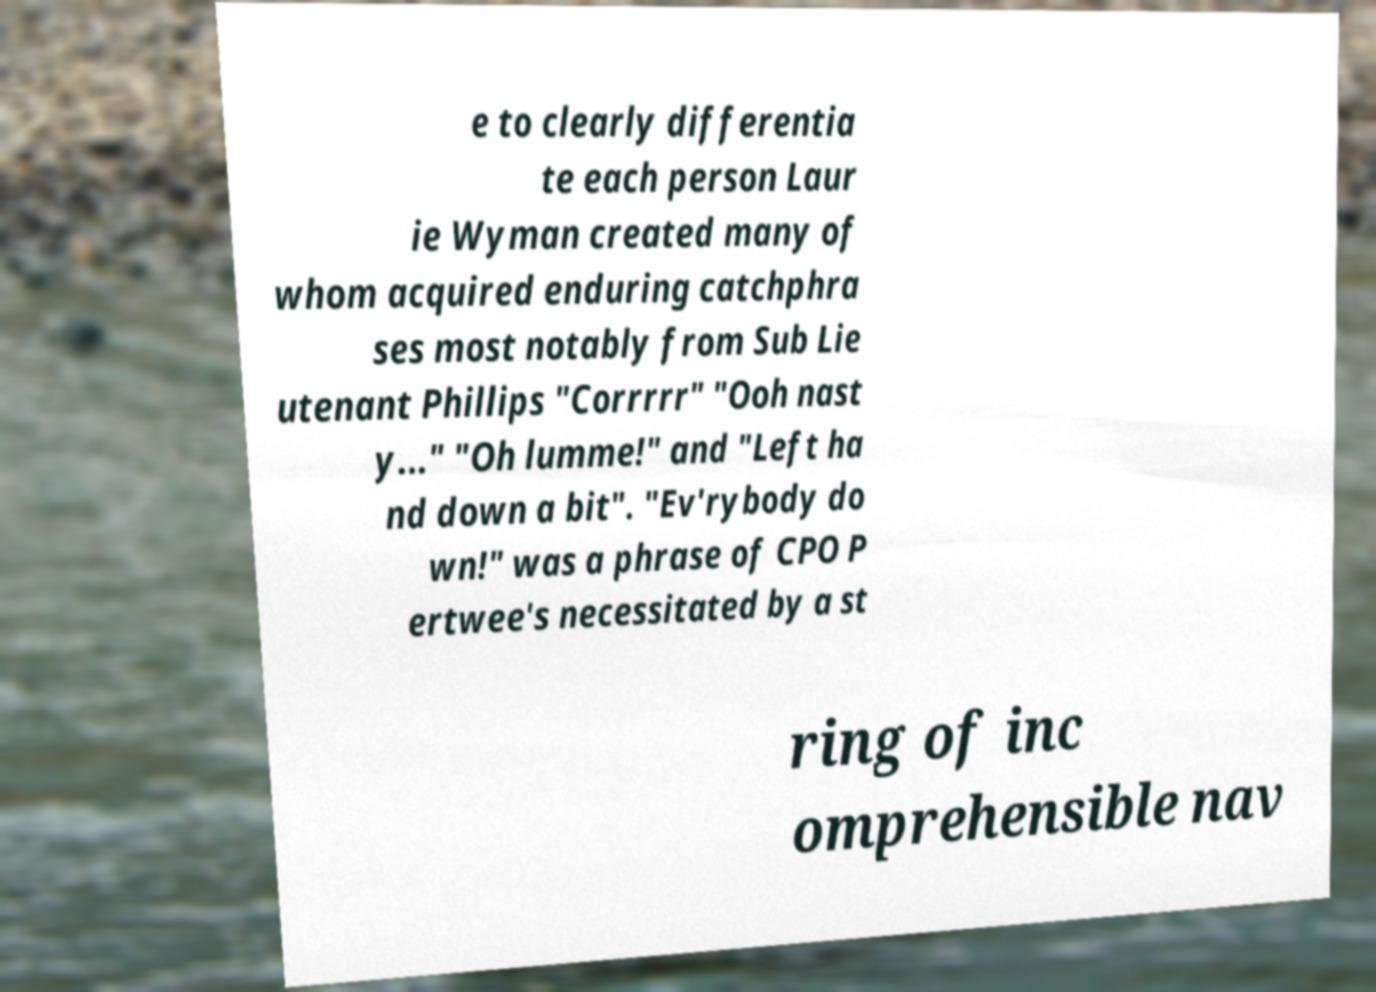Could you assist in decoding the text presented in this image and type it out clearly? e to clearly differentia te each person Laur ie Wyman created many of whom acquired enduring catchphra ses most notably from Sub Lie utenant Phillips "Corrrrr" "Ooh nast y..." "Oh lumme!" and "Left ha nd down a bit". "Ev'rybody do wn!" was a phrase of CPO P ertwee's necessitated by a st ring of inc omprehensible nav 